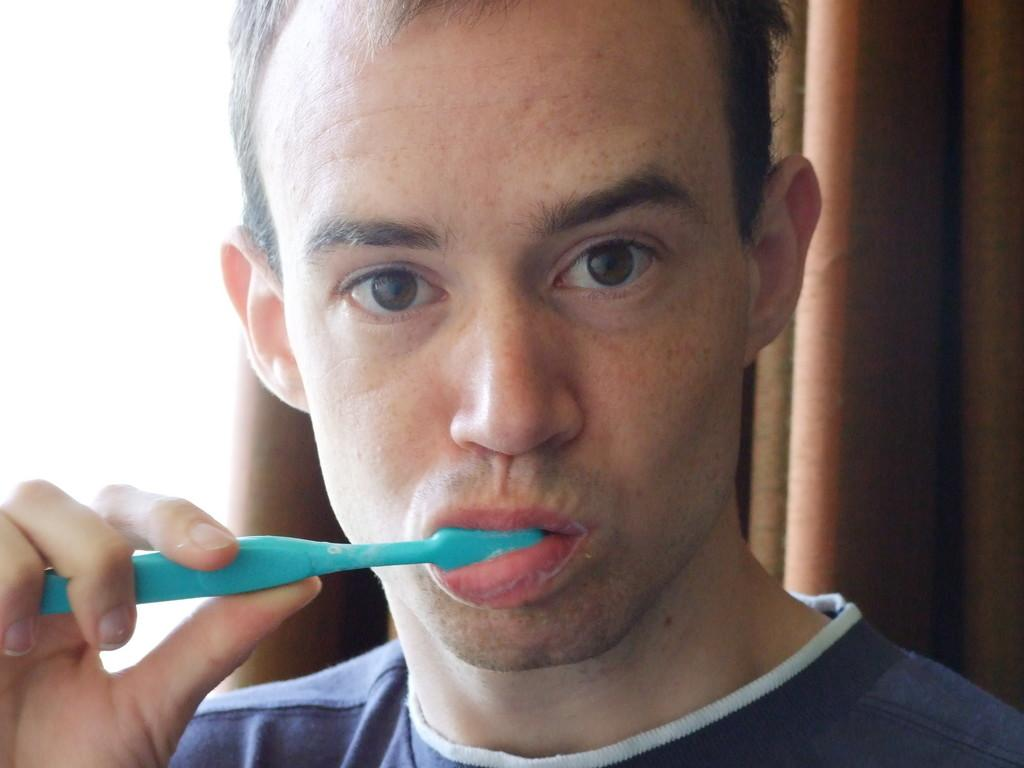What is the main subject of the image? There is a person in the image. What is the person holding in the image? The person is holding a blue color brush. What color is the background of the image? The background of the image is brown. Reasoning: Let's think step by following the guidelines to produce the conversation. We start by identifying the main subject of the image, which is the person. Then, we describe what the person is holding, which is a blue color brush. Finally, we mention the color of the background, which is brown. We avoid yes/no questions and ensure that the language is simple and clear. Absurd Question/Answer: How much money is the person holding in the image? There is no money visible in the image; the person is holding a blue color brush. What type of match is the person using in the image? There is no match present in the image; the person is holding a blue color brush. What type of jeans is the person wearing in the image? There is no information about the person's clothing in the image, so we cannot determine if they are wearing jeans or any other type of clothing. 